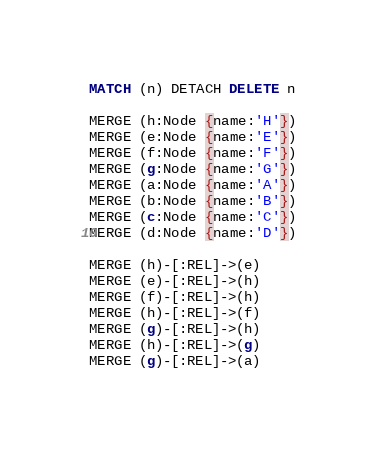Convert code to text. <code><loc_0><loc_0><loc_500><loc_500><_SQL_>MATCH (n) DETACH DELETE n

MERGE (h:Node {name:'H'})
MERGE (e:Node {name:'E'})
MERGE (f:Node {name:'F'})
MERGE (g:Node {name:'G'})
MERGE (a:Node {name:'A'})
MERGE (b:Node {name:'B'})
MERGE (c:Node {name:'C'})
MERGE (d:Node {name:'D'})

MERGE (h)-[:REL]->(e)
MERGE (e)-[:REL]->(h)
MERGE (f)-[:REL]->(h)
MERGE (h)-[:REL]->(f)
MERGE (g)-[:REL]->(h)
MERGE (h)-[:REL]->(g)
MERGE (g)-[:REL]->(a)</code> 